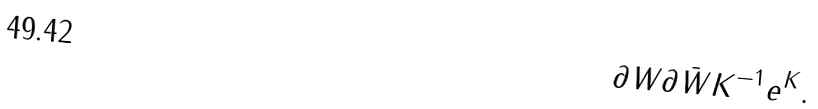Convert formula to latex. <formula><loc_0><loc_0><loc_500><loc_500>\partial W \partial \bar { W } K ^ { - 1 } e ^ { K } .</formula> 